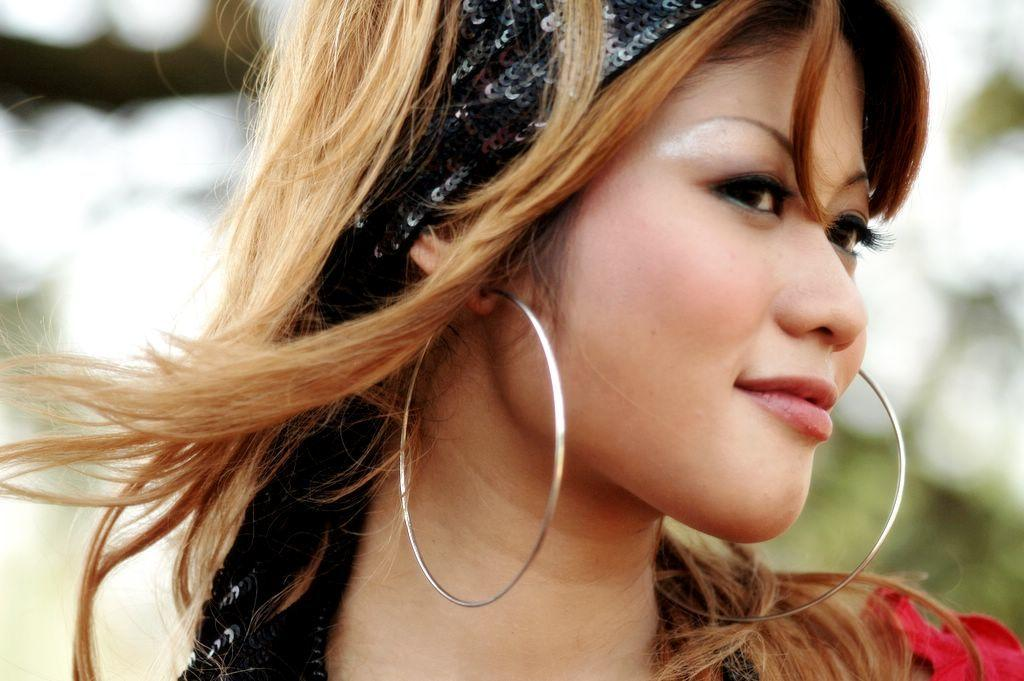Who is present in the image? There is a woman in the image. What is the woman's facial expression? The woman is smiling. Can you describe the background of the image? The background of the image is blurred. What type of shoes is the woman wearing in the image? There is no information about the woman's shoes in the image, as the focus is on her face and the background is blurred. 